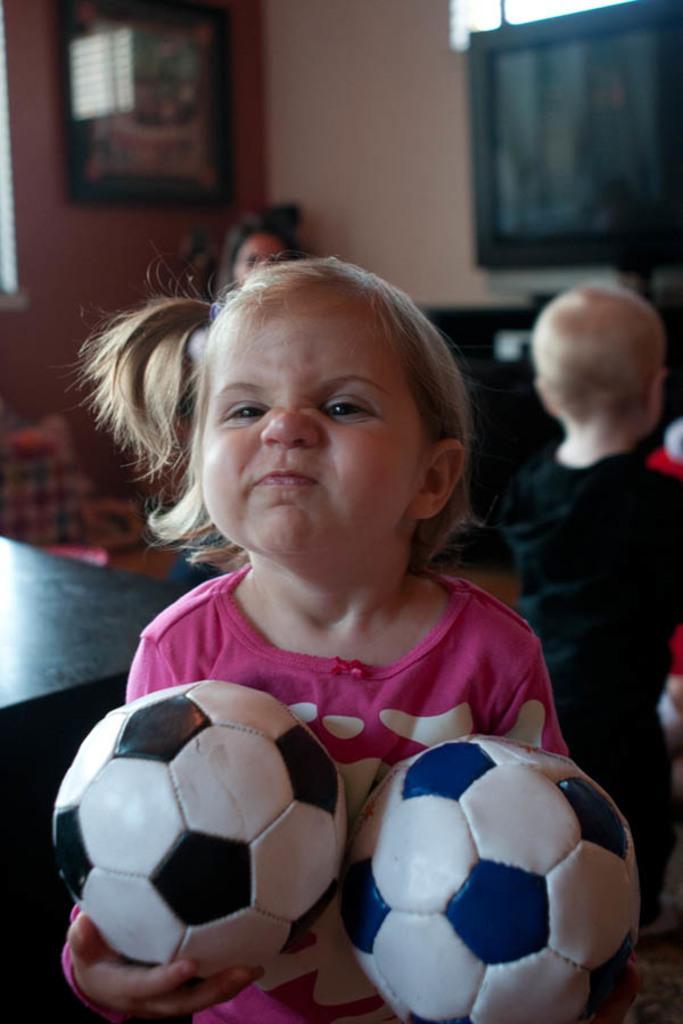Could you give a brief overview of what you see in this image? In this picture there is a girl wearing a pink dress and she is holding the two balls in the hands. In the background there is a television, a wall and two more persons. 